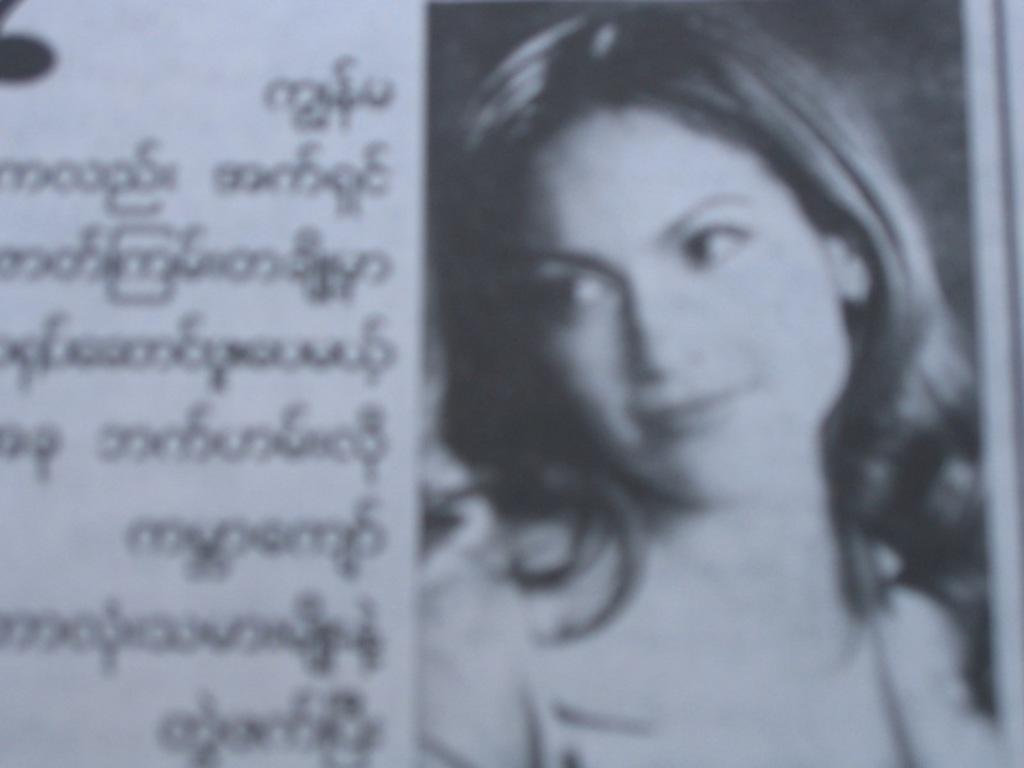Could you give a brief overview of what you see in this image? In this picture there is a news photograph. On the right side we can see a girl smiling and looking on the left side. Beside there is some matter in the paper. 